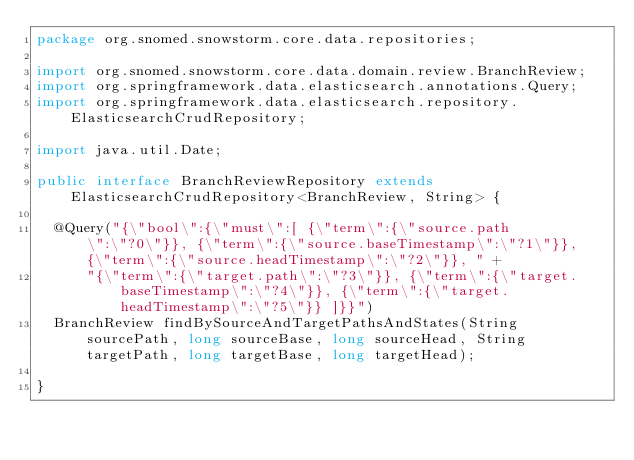<code> <loc_0><loc_0><loc_500><loc_500><_Java_>package org.snomed.snowstorm.core.data.repositories;

import org.snomed.snowstorm.core.data.domain.review.BranchReview;
import org.springframework.data.elasticsearch.annotations.Query;
import org.springframework.data.elasticsearch.repository.ElasticsearchCrudRepository;

import java.util.Date;

public interface BranchReviewRepository extends ElasticsearchCrudRepository<BranchReview, String> {

	@Query("{\"bool\":{\"must\":[ {\"term\":{\"source.path\":\"?0\"}}, {\"term\":{\"source.baseTimestamp\":\"?1\"}}, {\"term\":{\"source.headTimestamp\":\"?2\"}}, " +
			"{\"term\":{\"target.path\":\"?3\"}}, {\"term\":{\"target.baseTimestamp\":\"?4\"}}, {\"term\":{\"target.headTimestamp\":\"?5\"}} ]}}")
	BranchReview findBySourceAndTargetPathsAndStates(String sourcePath, long sourceBase, long sourceHead, String targetPath, long targetBase, long targetHead);

}
</code> 